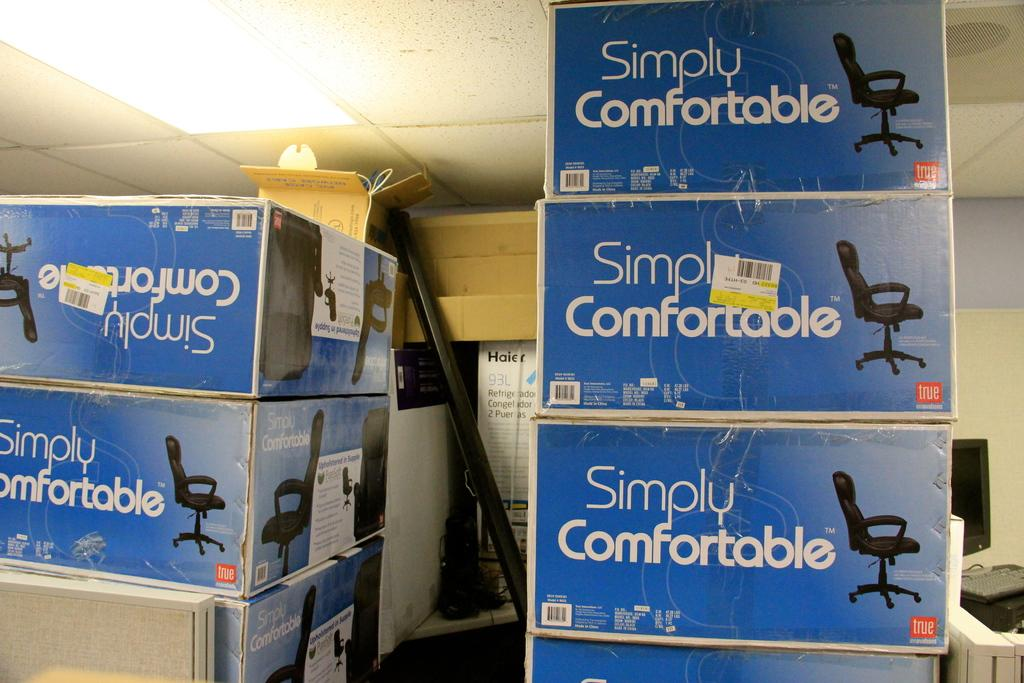<image>
Write a terse but informative summary of the picture. Many boxes of chairs that claim to be simply comfortable. 